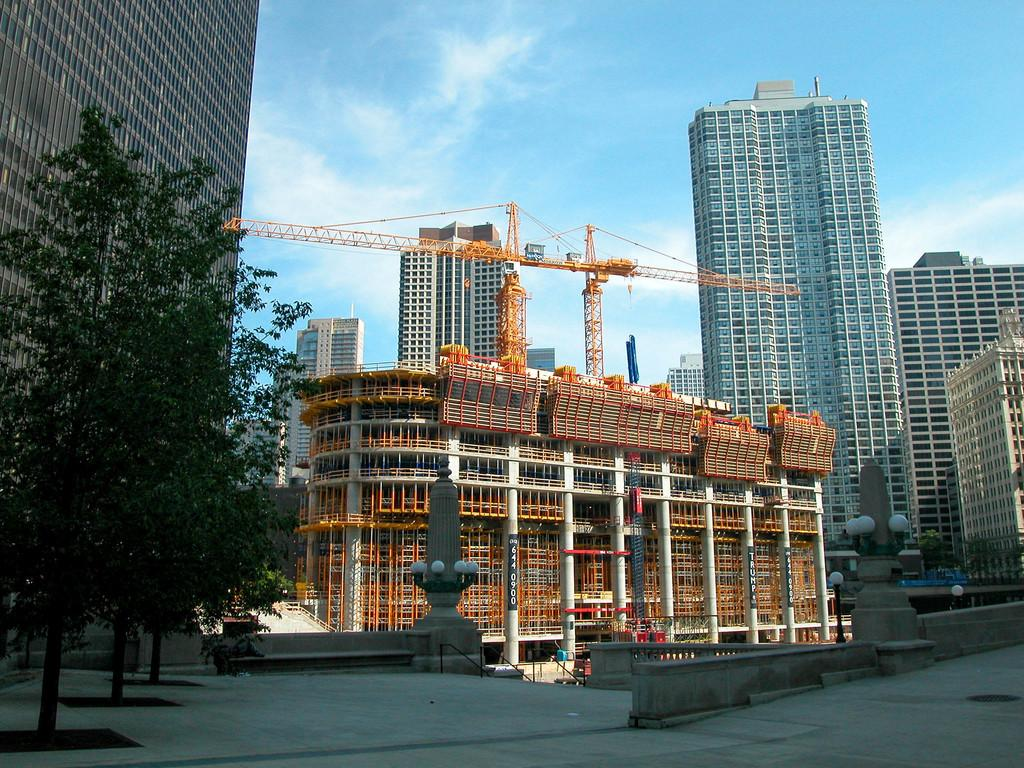What type of vegetation can be seen in the image? There are trees in the image. What type of structure is present in the image? There is a fence in the image. What other objects can be seen in the image? There are poles, buildings, and metal rods in the image. What is the color of the sky in the image? The sky is blue and visible at the top of the image. Can you describe the possible setting of the image? The image may have been taken on a road. What type of caption is written on the trees in the image? There is no caption written on the trees in the image. Can you see any bears in the image? There are no bears present in the image. What type of trousers are the trees wearing in the image? Trees do not wear trousers, as they are not living beings capable of wearing clothing. 